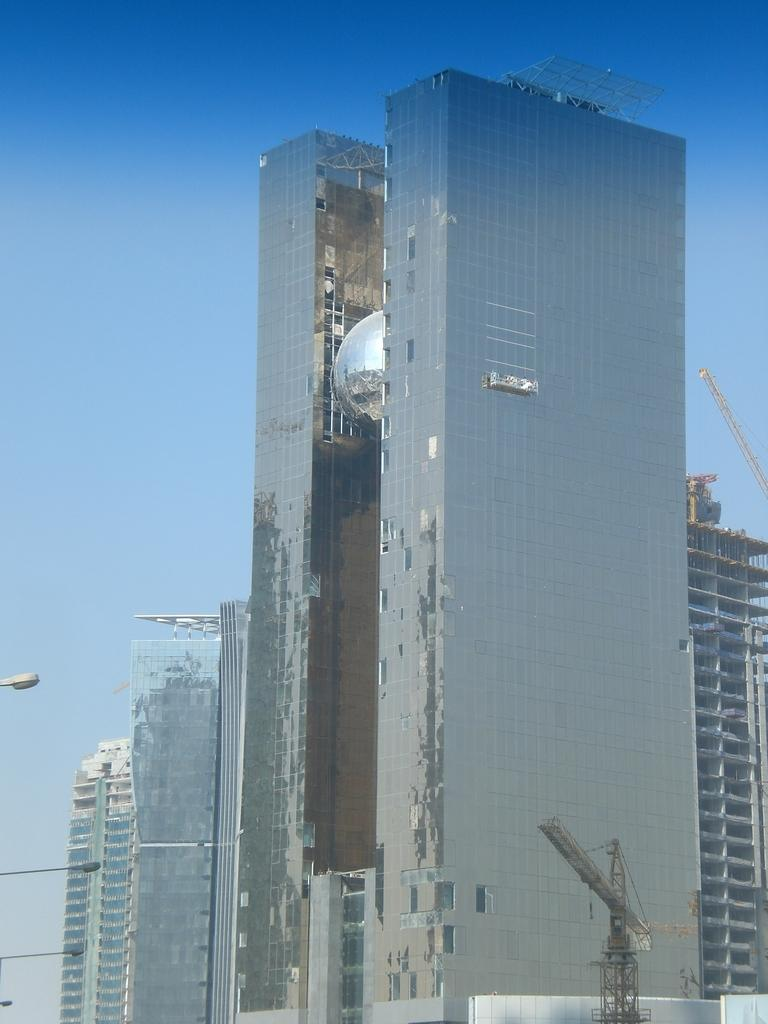What type of structures are located in the center of the image? There are buildings and skyscrapers in the center of the image. What other tall structures can be seen in the image? There are towers in the image. What is visible in the background of the image? The sky is visible in the background of the image. Where are the lights located in the image? The lights are on the left side of the image. What type of cave can be seen in the image? There is no cave present in the image; it features buildings, skyscrapers, towers, and lights. What company is responsible for the lights on the left side of the image? There is no information about a company responsible for the lights in the image. 